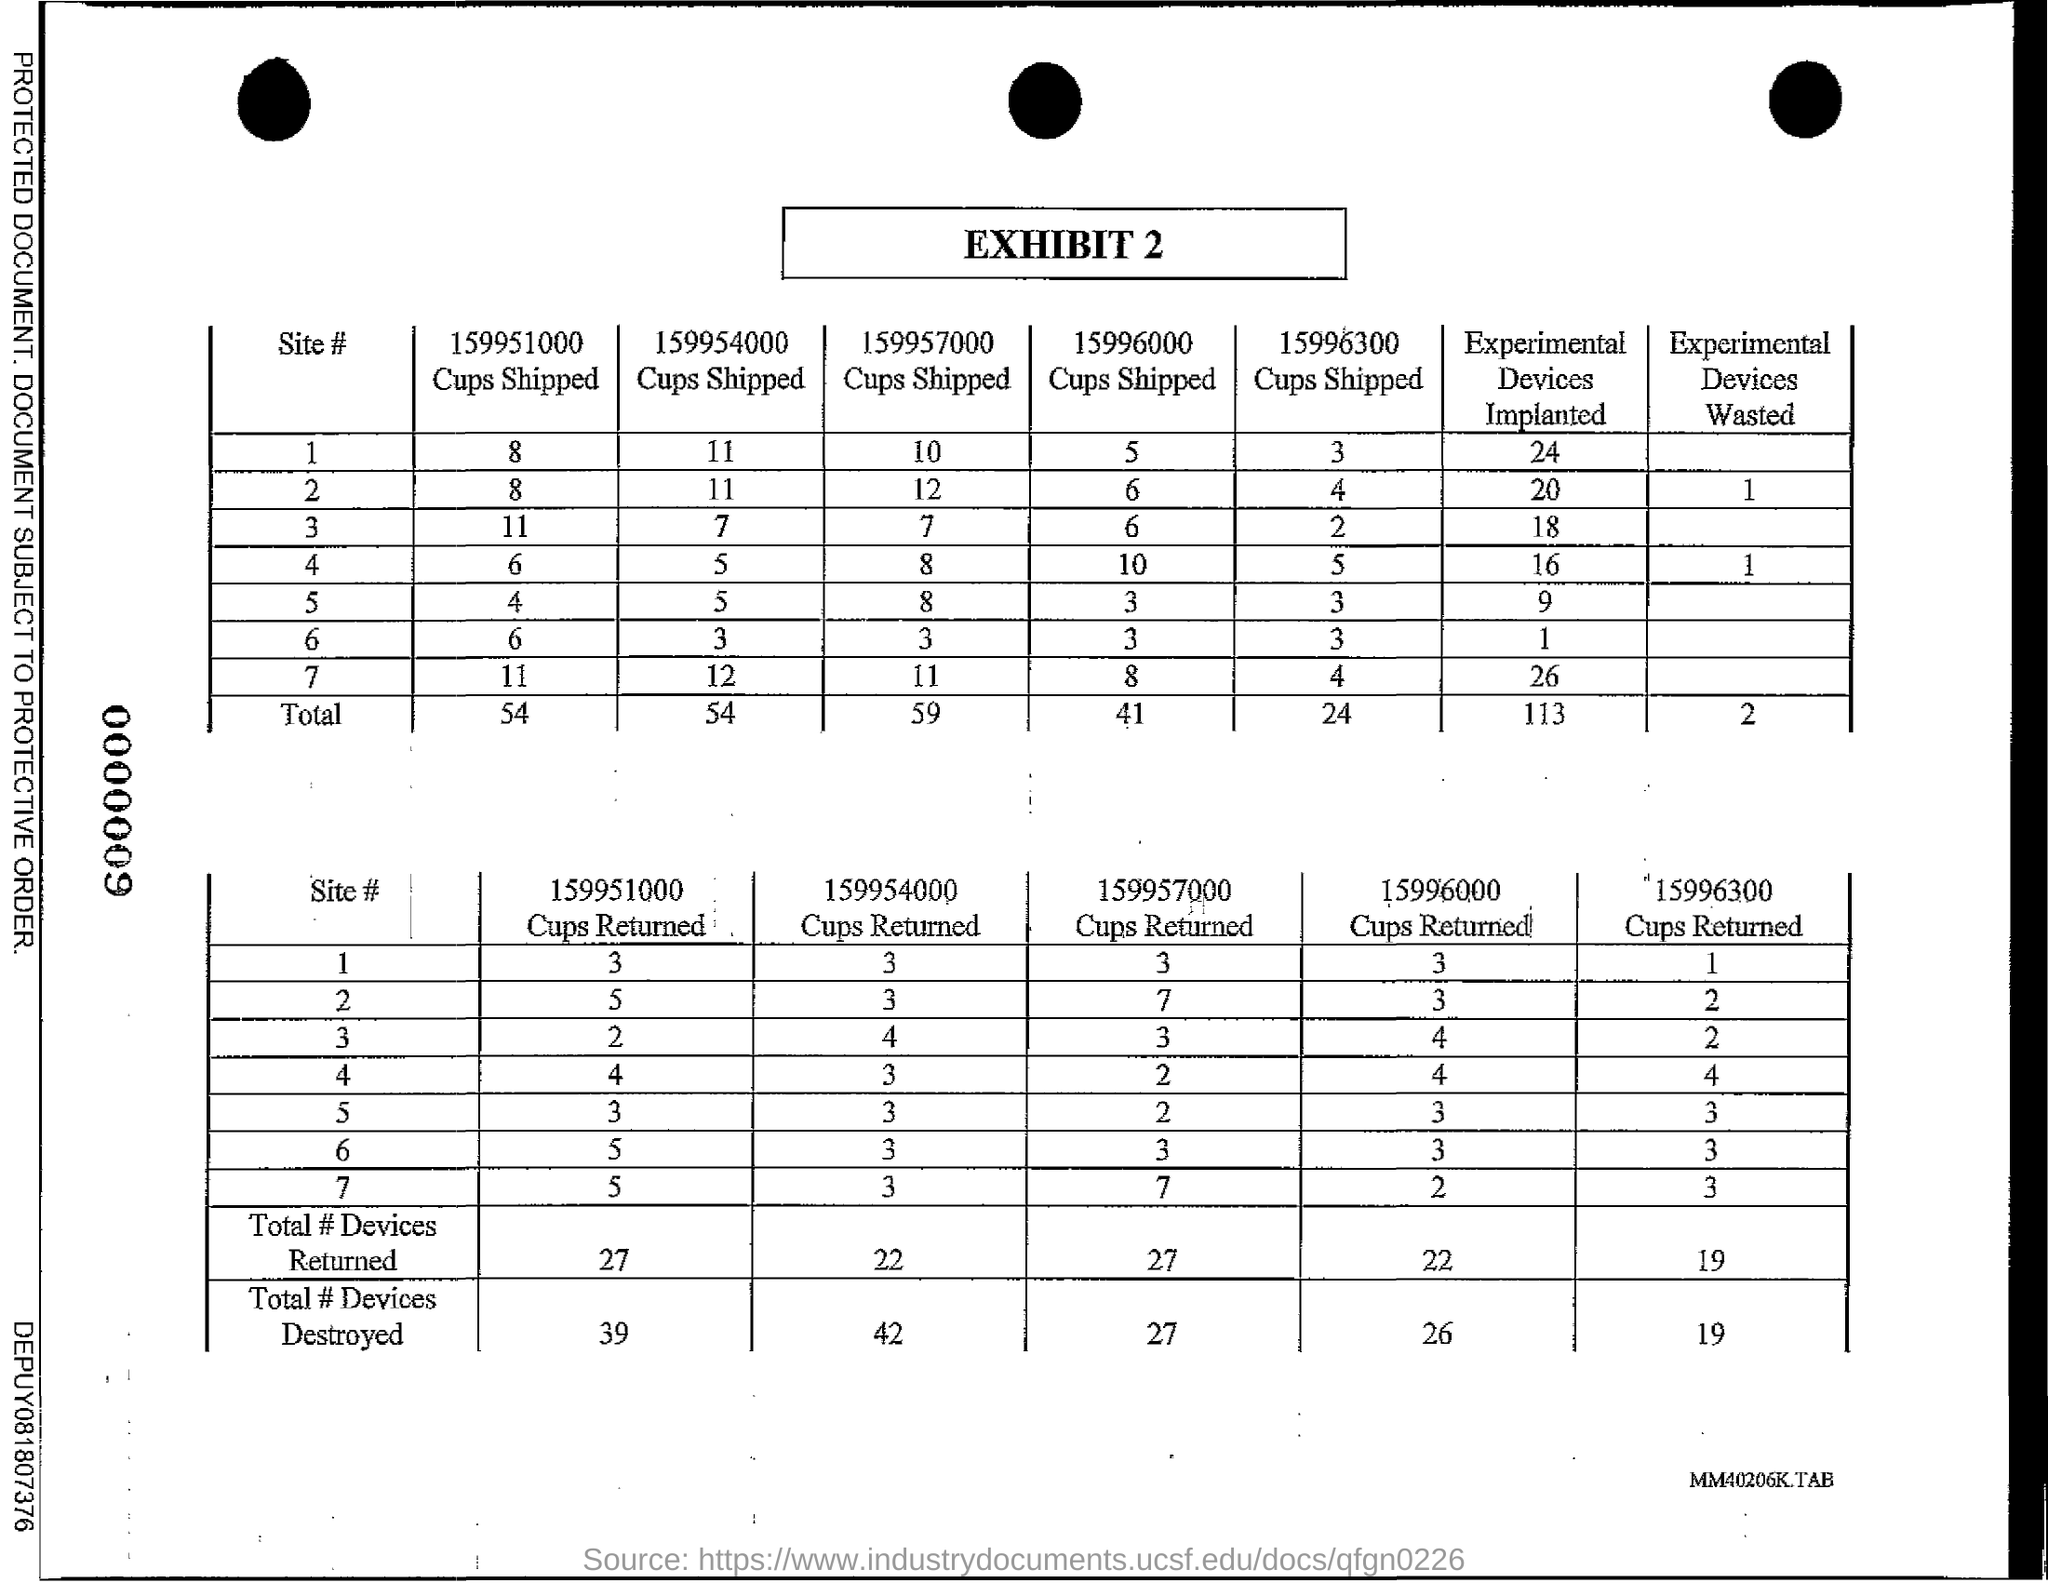Identify some key points in this picture. Exhibit number 2... 